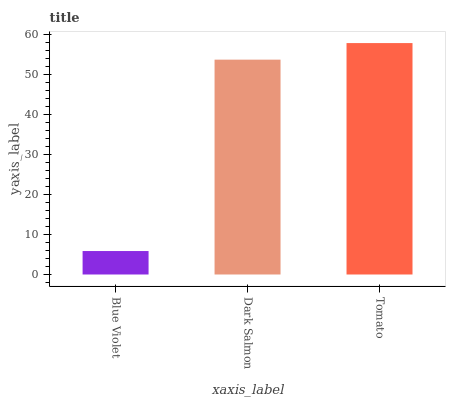Is Blue Violet the minimum?
Answer yes or no. Yes. Is Tomato the maximum?
Answer yes or no. Yes. Is Dark Salmon the minimum?
Answer yes or no. No. Is Dark Salmon the maximum?
Answer yes or no. No. Is Dark Salmon greater than Blue Violet?
Answer yes or no. Yes. Is Blue Violet less than Dark Salmon?
Answer yes or no. Yes. Is Blue Violet greater than Dark Salmon?
Answer yes or no. No. Is Dark Salmon less than Blue Violet?
Answer yes or no. No. Is Dark Salmon the high median?
Answer yes or no. Yes. Is Dark Salmon the low median?
Answer yes or no. Yes. Is Tomato the high median?
Answer yes or no. No. Is Tomato the low median?
Answer yes or no. No. 